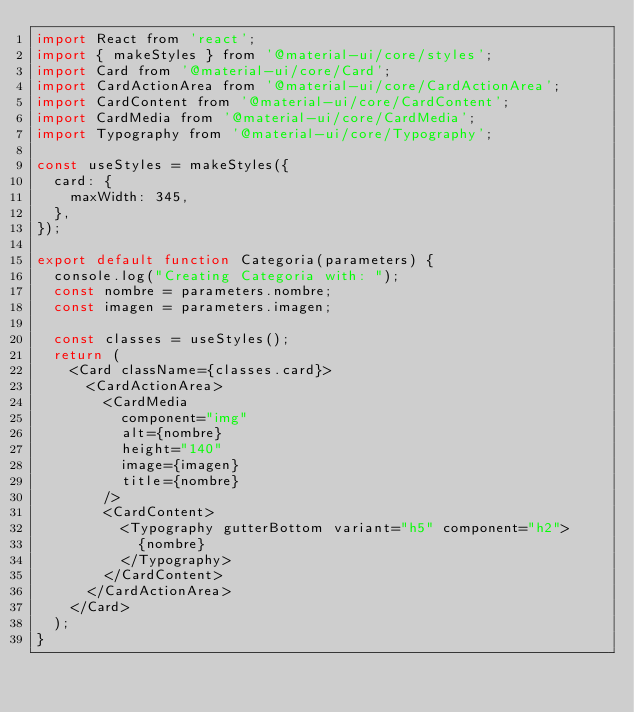<code> <loc_0><loc_0><loc_500><loc_500><_JavaScript_>import React from 'react';
import { makeStyles } from '@material-ui/core/styles';
import Card from '@material-ui/core/Card';
import CardActionArea from '@material-ui/core/CardActionArea';
import CardContent from '@material-ui/core/CardContent';
import CardMedia from '@material-ui/core/CardMedia';
import Typography from '@material-ui/core/Typography';

const useStyles = makeStyles({
  card: {
    maxWidth: 345,
  },
});

export default function Categoria(parameters) {
  console.log("Creating Categoria with: ");
  const nombre = parameters.nombre;
  const imagen = parameters.imagen;

  const classes = useStyles();
  return (
    <Card className={classes.card}>
      <CardActionArea>
        <CardMedia
          component="img"
          alt={nombre}
          height="140"
          image={imagen}
          title={nombre}
        />
        <CardContent>
          <Typography gutterBottom variant="h5" component="h2">
            {nombre}
          </Typography>
        </CardContent>
      </CardActionArea>
    </Card>
  );
}</code> 